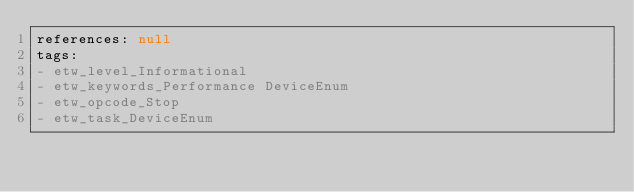<code> <loc_0><loc_0><loc_500><loc_500><_YAML_>references: null
tags:
- etw_level_Informational
- etw_keywords_Performance DeviceEnum
- etw_opcode_Stop
- etw_task_DeviceEnum
</code> 